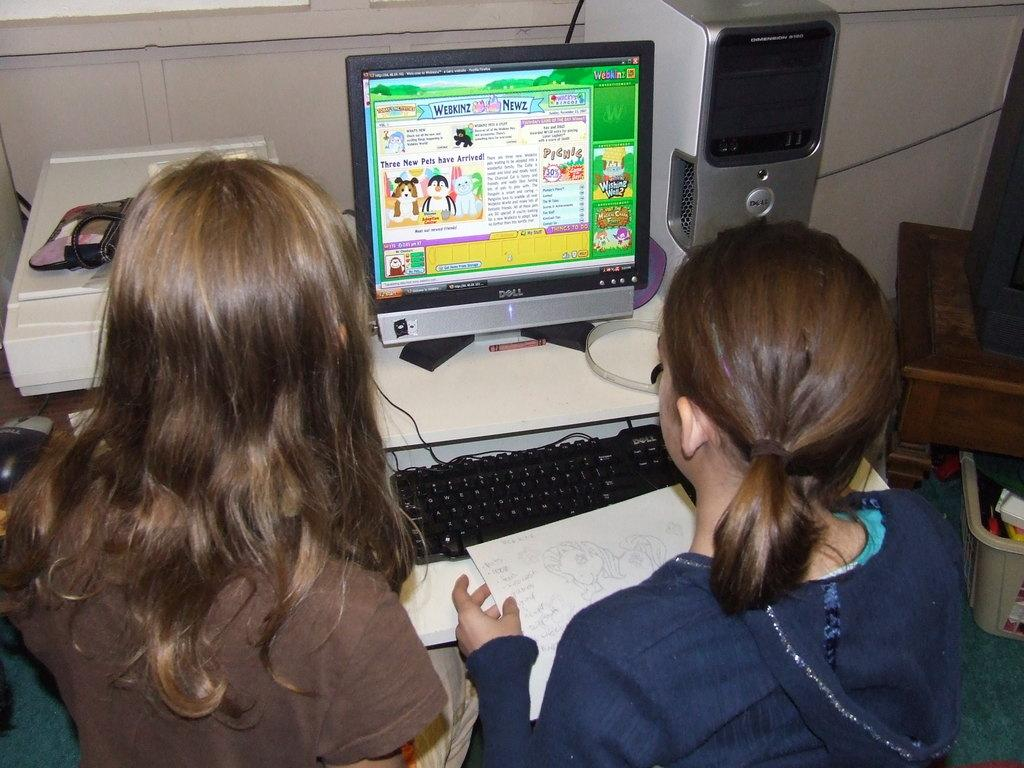How many women are in the image? There are two women in the image. What are the women doing in the image? The women are sitting in the image. What are the women holding in their hands? The women are holding paper in their hands. What electronic devices are visible in the image? There is a monitor, a CPU, and a keyboard in the image. Where are the electronic devices located in the image? The monitor, CPU, and keyboard are on a table in the image. What type of birds can be seen flying around the women in the image? There are no birds visible in the image. What news story is the cow discussing with the women in the image? There is no cow or news story present in the image. 